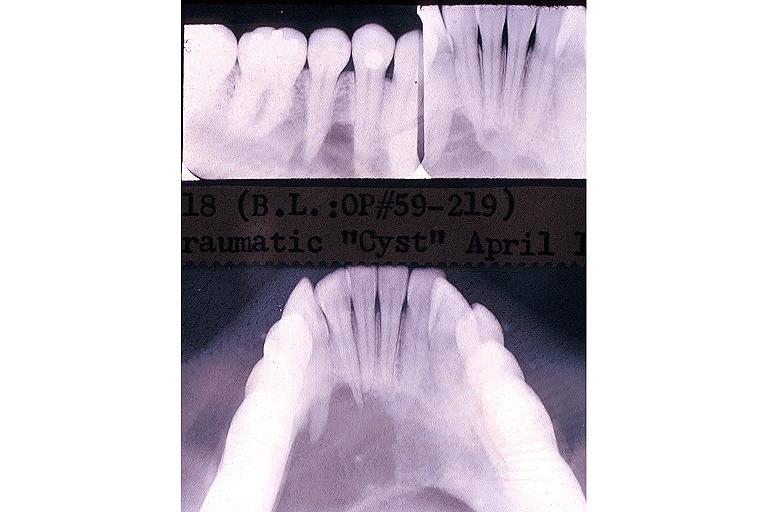s male reproductive present?
Answer the question using a single word or phrase. No 